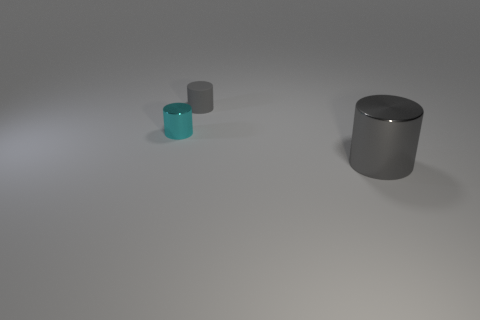Add 1 cylinders. How many objects exist? 4 Add 2 large red spheres. How many large red spheres exist? 2 Subtract 2 gray cylinders. How many objects are left? 1 Subtract all cyan cylinders. Subtract all gray metallic cylinders. How many objects are left? 1 Add 2 small metallic cylinders. How many small metallic cylinders are left? 3 